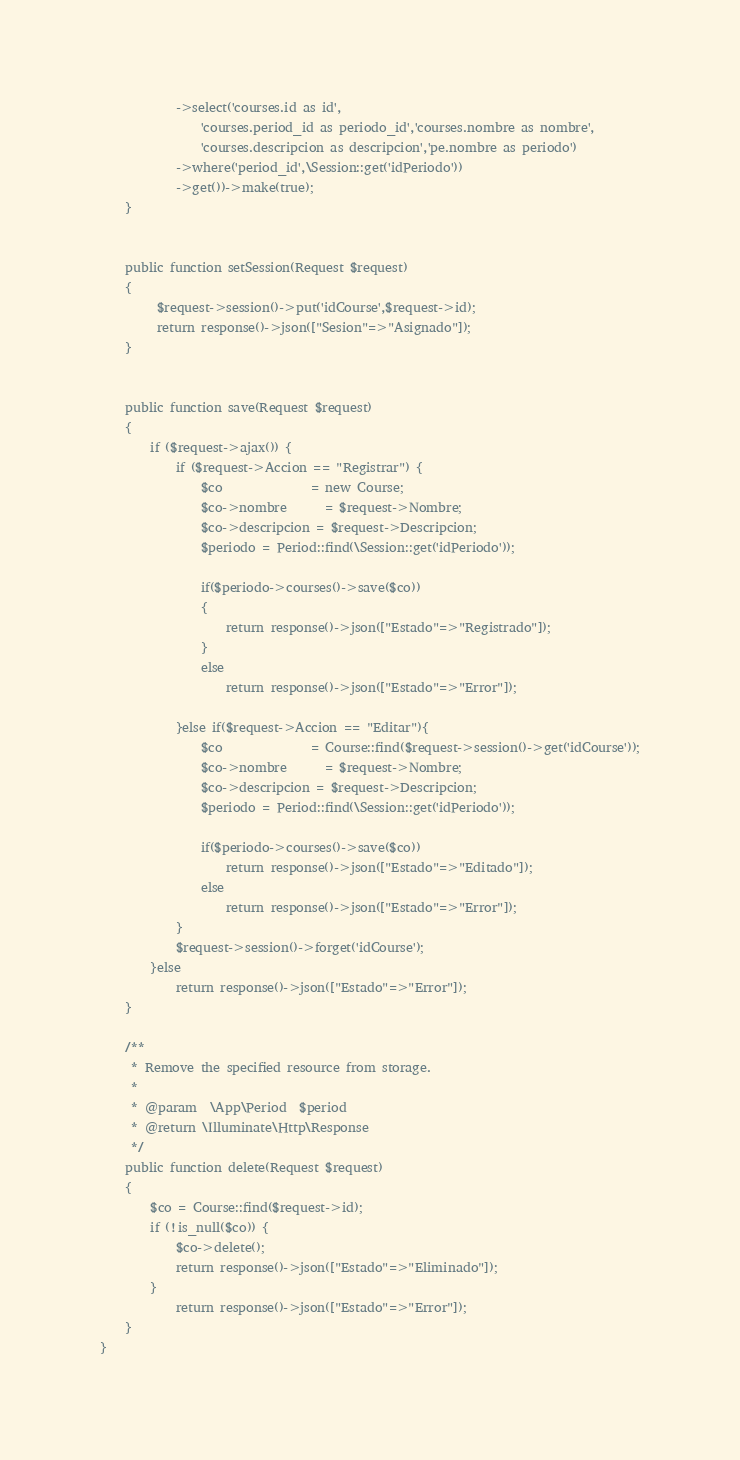Convert code to text. <code><loc_0><loc_0><loc_500><loc_500><_PHP_>            ->select('courses.id as id',
                'courses.period_id as periodo_id','courses.nombre as nombre',
                'courses.descripcion as descripcion','pe.nombre as periodo')
            ->where('period_id',\Session::get('idPeriodo'))
            ->get())->make(true);
    }

    
    public function setSession(Request $request)
    {
         $request->session()->put('idCourse',$request->id);
         return response()->json(["Sesion"=>"Asignado"]);
    }


    public function save(Request $request)
    {
        if ($request->ajax()) {
            if ($request->Accion == "Registrar") {
                $co              = new Course;
                $co->nombre      = $request->Nombre;
                $co->descripcion = $request->Descripcion;
                $periodo = Period::find(\Session::get('idPeriodo'));

                if($periodo->courses()->save($co))
                {
                    return response()->json(["Estado"=>"Registrado"]);
                }
                else
                    return response()->json(["Estado"=>"Error"]);    
            
            }else if($request->Accion == "Editar"){
                $co              = Course::find($request->session()->get('idCourse'));
                $co->nombre      = $request->Nombre;
                $co->descripcion = $request->Descripcion;
                $periodo = Period::find(\Session::get('idPeriodo'));

                if($periodo->courses()->save($co))
                    return response()->json(["Estado"=>"Editado"]);
                else
                    return response()->json(["Estado"=>"Error"]);    
            } 
            $request->session()->forget('idCourse');
        }else
            return response()->json(["Estado"=>"Error"]);
    }

    /**
     * Remove the specified resource from storage.
     *
     * @param  \App\Period  $period
     * @return \Illuminate\Http\Response
     */
    public function delete(Request $request)
    {
        $co = Course::find($request->id);
        if (!is_null($co)) {
            $co->delete();
            return response()->json(["Estado"=>"Eliminado"]);
        }
            return response()->json(["Estado"=>"Error"]);
    }
}
</code> 